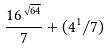Convert formula to latex. <formula><loc_0><loc_0><loc_500><loc_500>\frac { 1 6 ^ { \sqrt { 6 4 } } } { 7 } + ( 4 ^ { 1 } / 7 )</formula> 